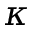<formula> <loc_0><loc_0><loc_500><loc_500>\kappa</formula> 